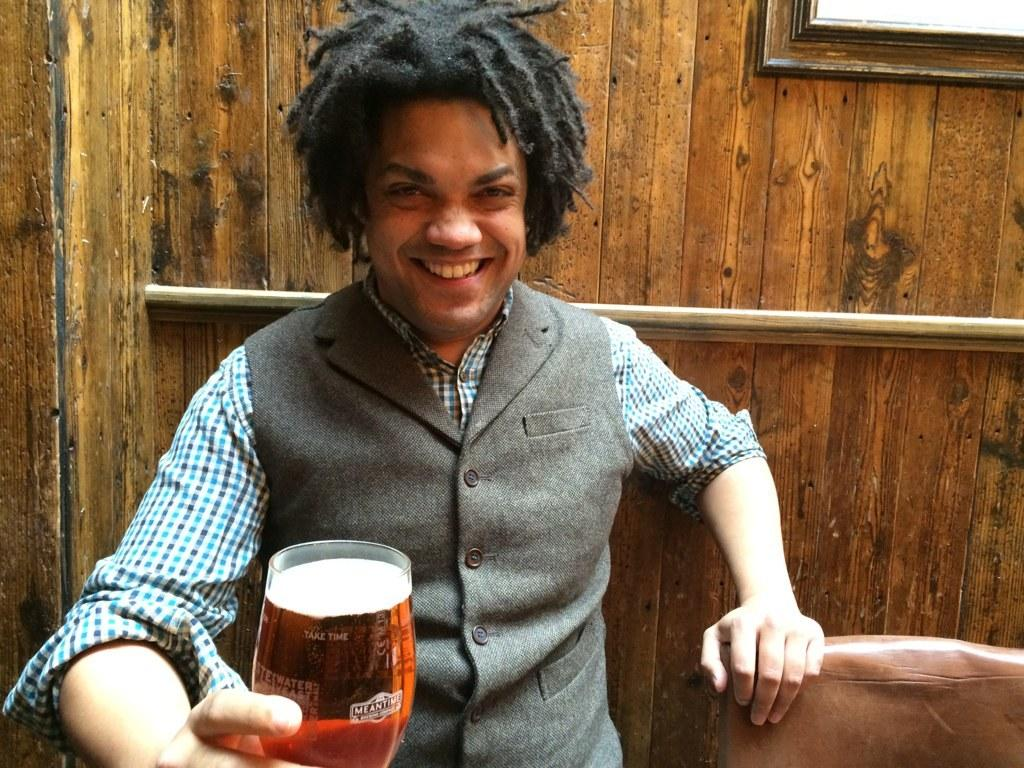What is the main subject of the image? There is a man in the image. What is the man wearing? The man is wearing a vest coat. What expression does the man have? The man is smiling. What is the man holding in the image? The man is holding a beer glass. What can be seen in the background of the image? There is a wooden wall in the background of the image. Are there any dinosaurs visible in the image? No, there are no dinosaurs present in the image. Can you see any cobwebs on the wooden wall in the background? The image does not show any cobwebs on the wooden wall. 